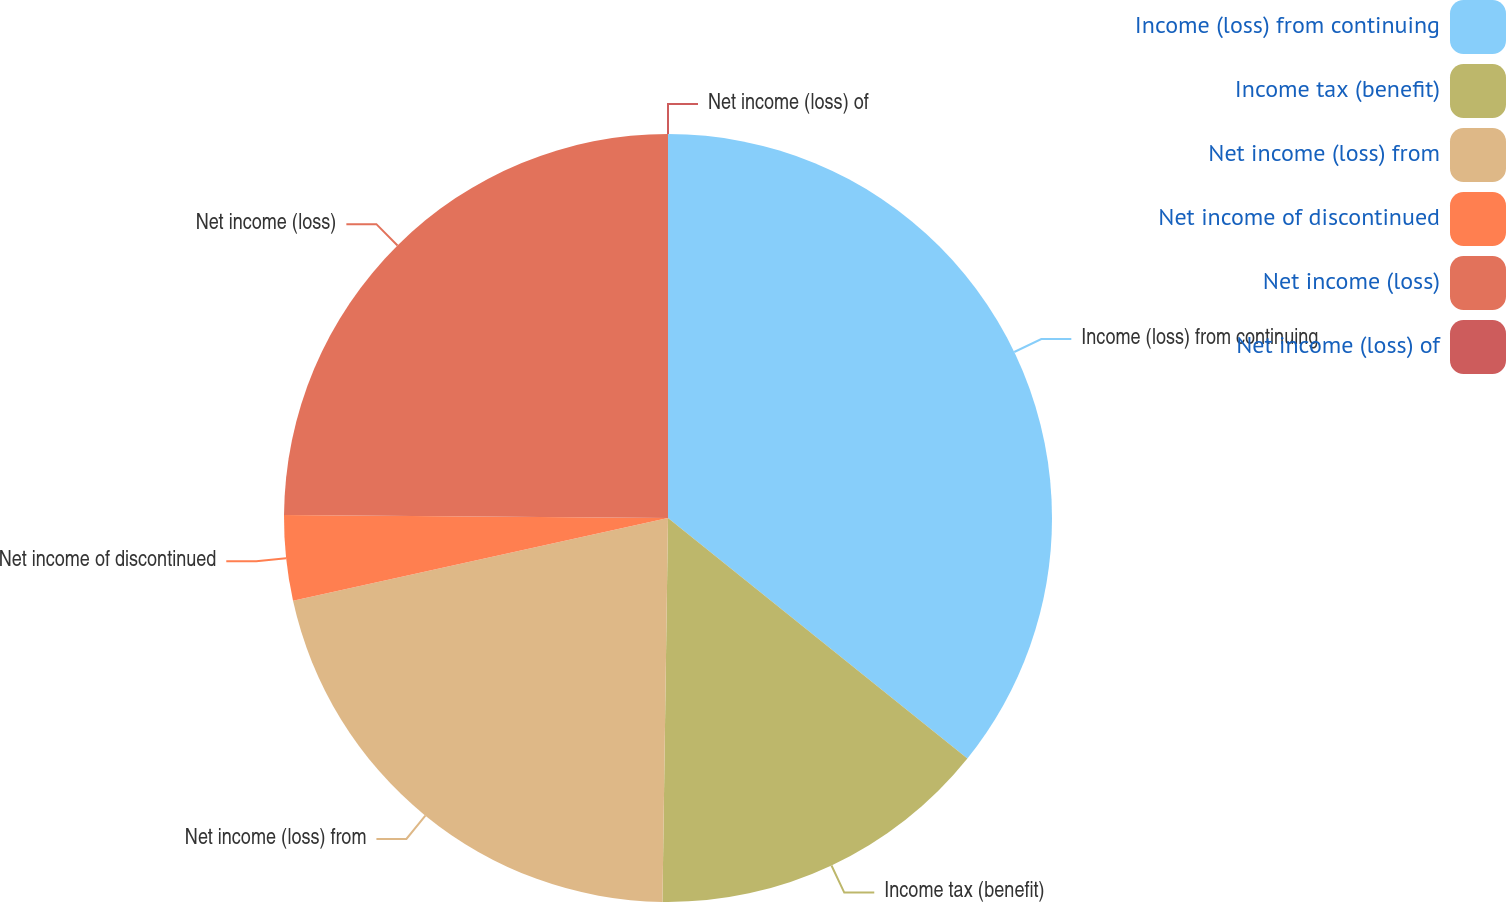<chart> <loc_0><loc_0><loc_500><loc_500><pie_chart><fcel>Income (loss) from continuing<fcel>Income tax (benefit)<fcel>Net income (loss) from<fcel>Net income of discontinued<fcel>Net income (loss)<fcel>Net income (loss) of<nl><fcel>35.77%<fcel>14.46%<fcel>21.31%<fcel>3.58%<fcel>24.88%<fcel>0.0%<nl></chart> 